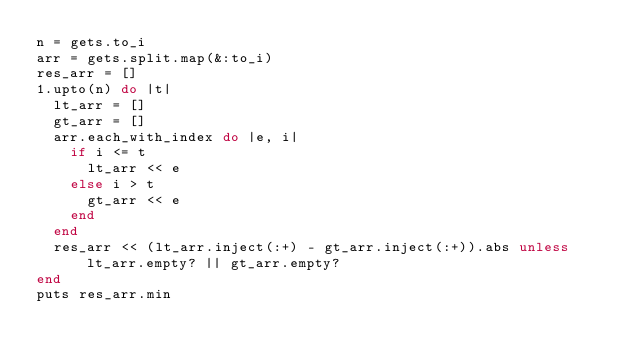Convert code to text. <code><loc_0><loc_0><loc_500><loc_500><_Ruby_>n = gets.to_i
arr = gets.split.map(&:to_i)
res_arr = []
1.upto(n) do |t|
  lt_arr = []
  gt_arr = []
  arr.each_with_index do |e, i|
    if i <= t
      lt_arr << e
    else i > t
      gt_arr << e
    end
  end
  res_arr << (lt_arr.inject(:+) - gt_arr.inject(:+)).abs unless lt_arr.empty? || gt_arr.empty?
end
puts res_arr.min</code> 